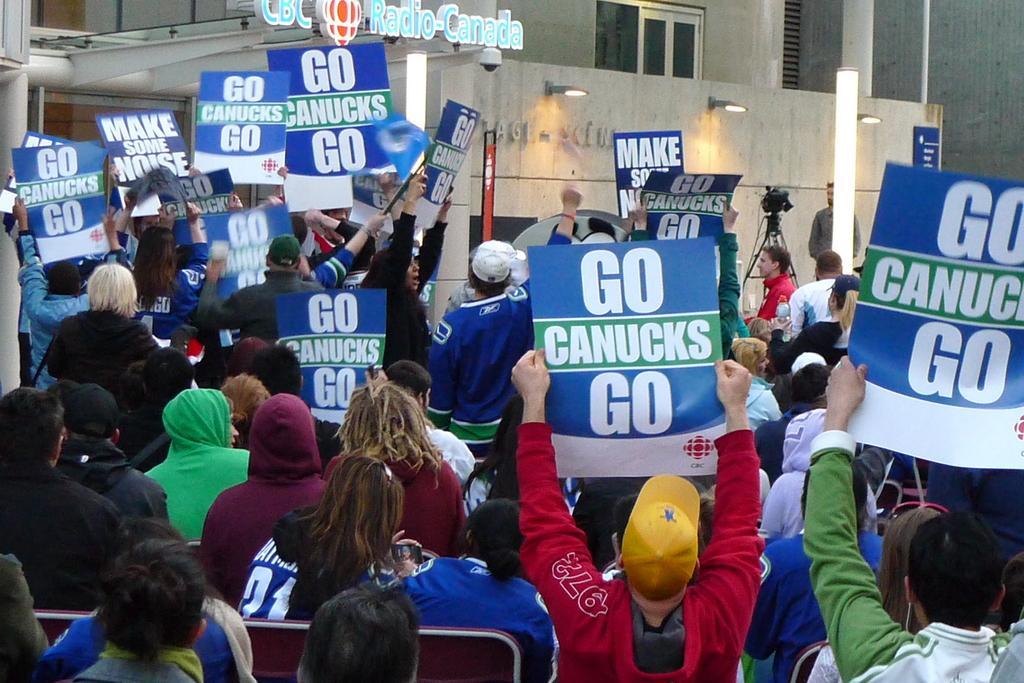Could you give a brief overview of what you see in this image? In this picture I can observe some people sitting in the benches and some are standing. Most of them are holding blue and white color posters in their hands. There is some text on these posters. There are men and women in this picture. In the background there is a building. 